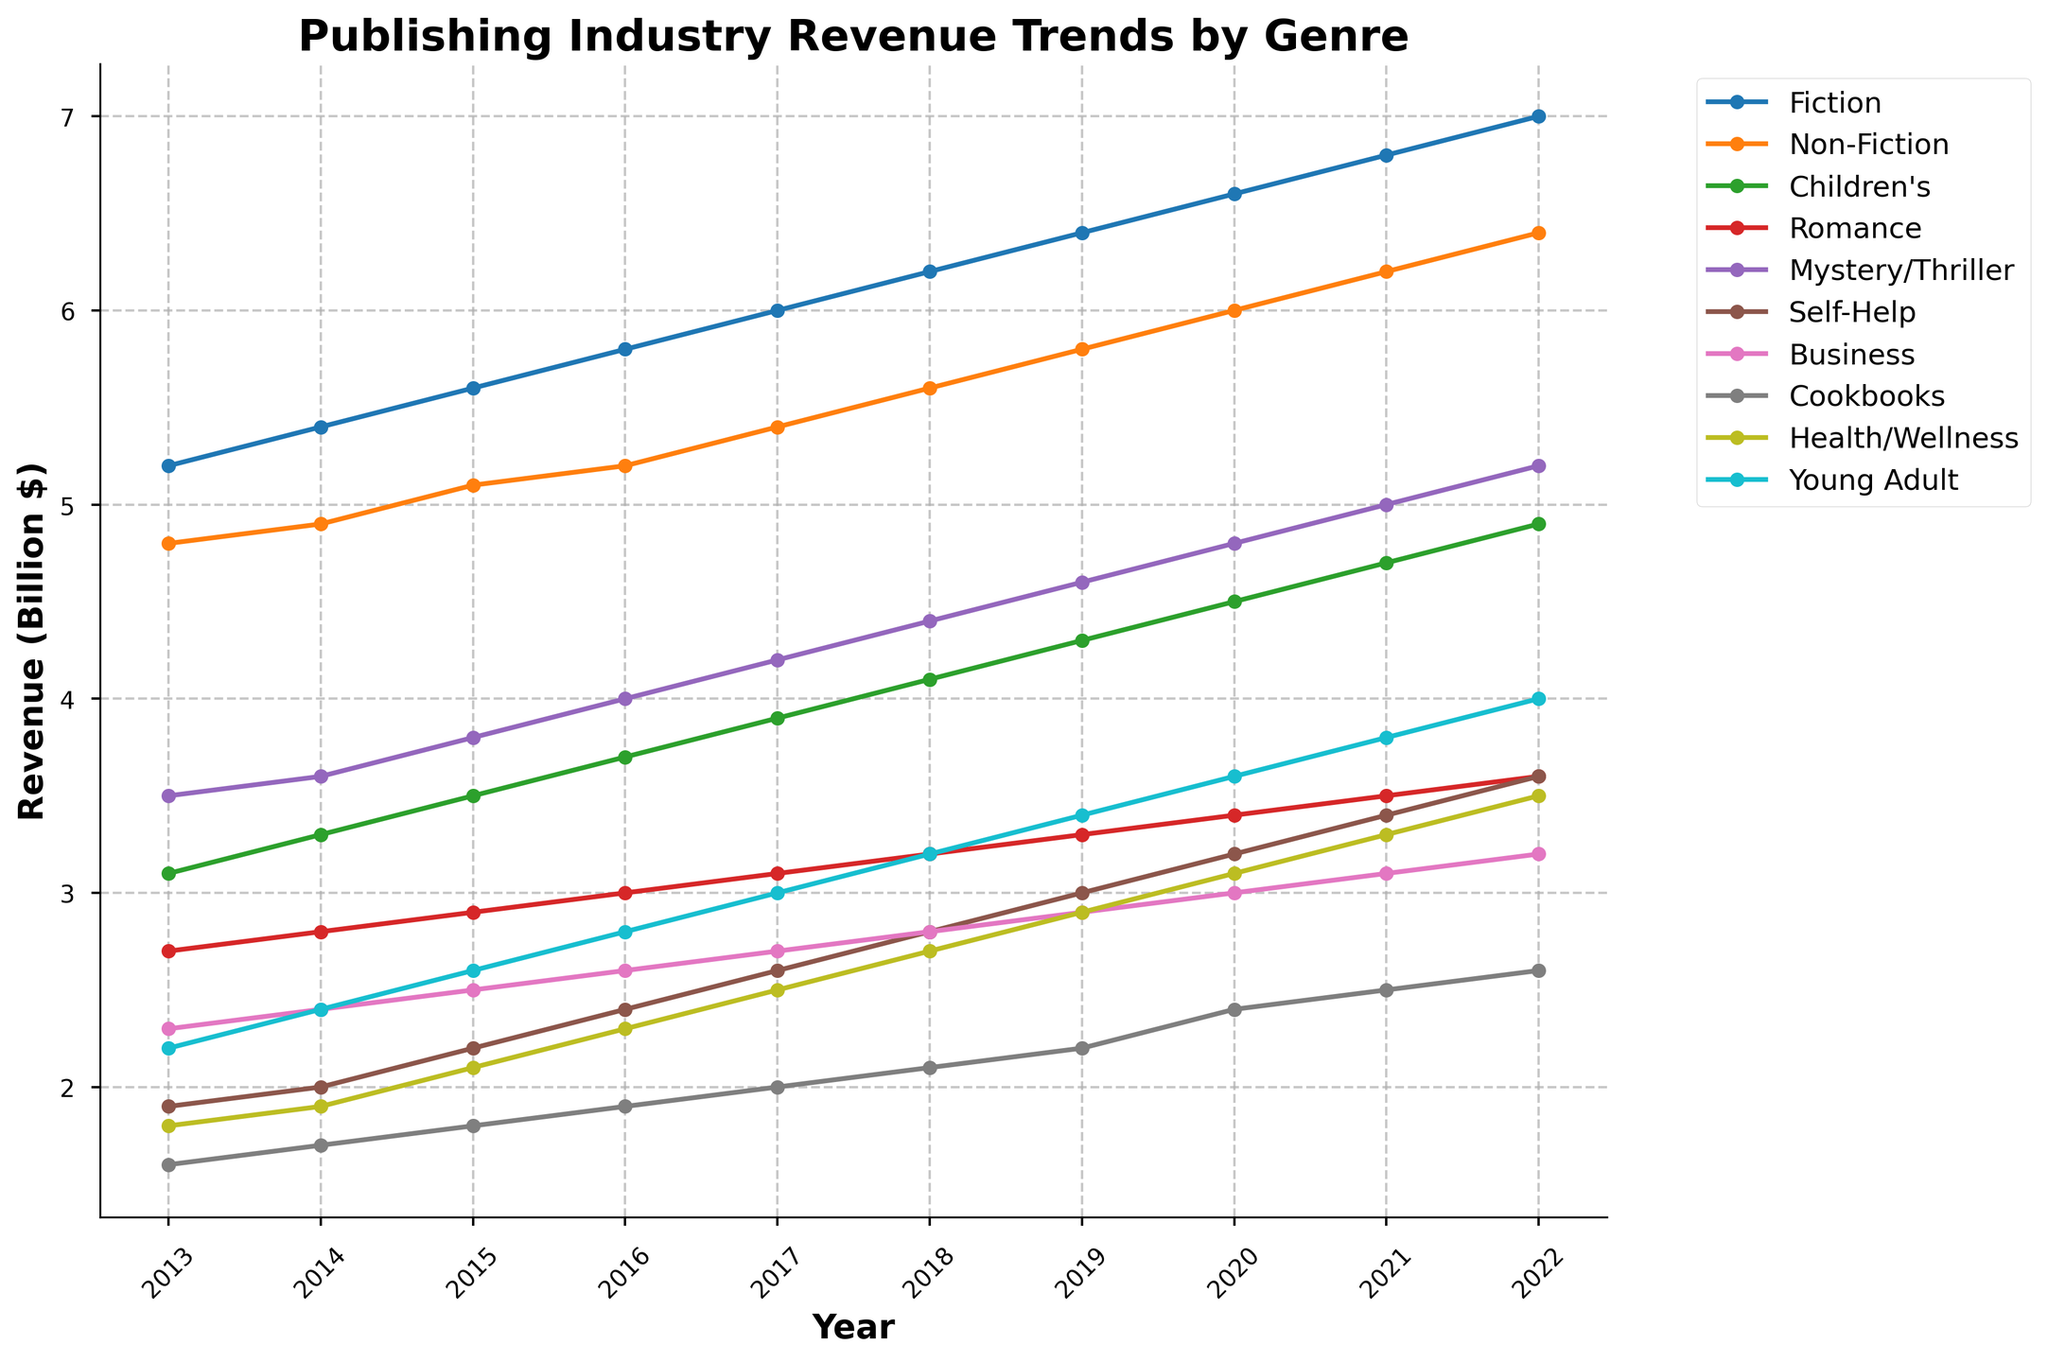What's the overall trend in revenue for Fiction from 2013 to 2022? To determine the trend, observe the line representing Fiction over the years on the graph. The line starts at about 5.2 billion dollars in 2013 and rises steadily to 7.0 billion dollars in 2022, showing a consistent upward trend.
Answer: Consistent upward trend Which genre had the highest revenue in 2022? Look for the end of the lines in 2022 and compare their heights. The Fiction genre has the highest ending point at 7.0 billion dollars.
Answer: Fiction Between Non-Fiction and Mystery/Thriller, which genre saw a greater increase in revenue from 2013 to 2022? Calculate the difference for both genres over the years: For Non-Fiction, it starts at 4.8 in 2013 and ends at 6.4 in 2022, an increase of 1.6 billion dollars. For Mystery/Thriller, it starts at 3.5 in 2013 and ends at 5.2 in 2022, an increase of 1.7 billion dollars.
Answer: Mystery/Thriller How much did the revenue for Children's books change from 2013 to 2022? The revenue for Children's books in 2013 was 3.1 billion dollars, and in 2022 it is 4.9 billion dollars. The change is calculated as 4.9 - 3.1 = 1.8 billion dollars.
Answer: 1.8 billion dollars Which genre has the most stable trend (least variation) over the years? Look for the line that changes the least in height throughout the graph. The Business genre has a relatively steady trend, with minimal fluctuation compared to others.
Answer: Business Which genre showed the largest growth rate between 2019 and 2020? Calculate the difference for each genre between 2019 and 2020: Fiction (6.4 to 6.6 = +0.2), Non-Fiction (5.8 to 6.0 = +0.2), Children's (4.3 to 4.5 = +0.2), Romance (3.3 to 3.4 = +0.1), Mystery/Thriller (4.6 to 4.8 = +0.2), Self-Help (3.0 to 3.2 = +0.2), Business (2.9 to 3.0 = +0.1), Cookbooks (2.2 to 2.4 = +0.2), Health/Wellness (2.9 to 3.1 = +0.2), and Young Adult (3.4 to 3.6 = +0.2). No genre showed the largest growth rate than the others within this specified period.
Answer: All genres with +0.2 Is there any genre that crosses another in terms of revenue from 2013 to 2022? Observe if any lines intersect each other during the period. Although lines get close, none of them actually cross, indicating no changes in rank.
Answer: No What is the total combined revenue for Fiction and Young Adult genres in 2015? Add the revenue of the two genres for the year 2015: Fiction (5.6) + Young Adult (2.6) = 8.2 billion dollars.
Answer: 8.2 billion dollars Which genre saw the smallest increase in revenue from 2013 to 2022? Calculate the increase for each genre by subtracting the 2013 value from the 2022 value: Fiction (7.0-5.2 = +1.8), Non-Fiction (6.4-4.8 = +1.6), Children's (4.9-3.1 = +1.8), Romance (3.6-2.7 = +0.9), Mystery/Thriller (5.2-3.5 = +1.7), Self-Help (3.6-1.9 = +1.7), Business (3.2-2.3 = +0.9), Cookbooks (2.6-1.6 = +1.0), Health/Wellness (3.5-1.8 = +1.7), Young Adult (4.0-2.2 = +1.8). The genre with the smallest increase is Romance and Business.
Answer: Romance and Business What's the combined revenue for Health/Wellness and Non-Fiction genres over the entire decade? Sum the annual revenues of Health/Wellness and Non-Fiction for each year from 2013 to 2022 and then add them up: Health/Wellness (1.8+1.9+2.1+2.3+2.5+2.7+2.9+3.1+3.3+3.5 = 25.1) and Non-Fiction (4.8+4.9+5.1+5.2+5.4+5.6+5.8+6.0+6.2+6.4 = 55.4). Total combined revenue = 25.1 + 55.4 = 80.5 billion dollars.
Answer: 80.5 billion dollars 